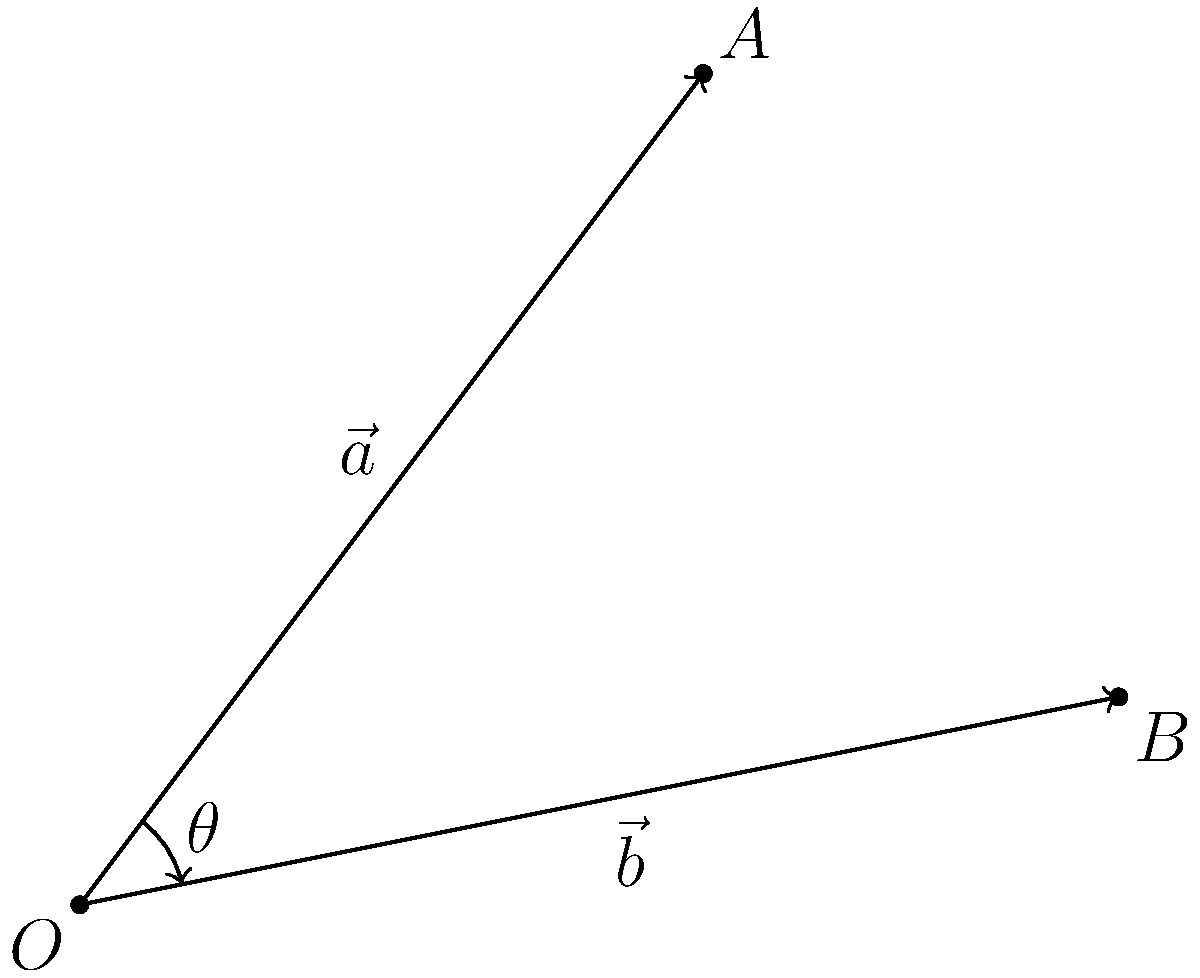In a biotech research project, you're analyzing the interaction between two protein vectors $\vec{a}$ and $\vec{b}$. Given that $\vec{a} = 3\hat{i} + 4\hat{j}$ and $\vec{b} = 5\hat{i} + \hat{j}$, calculate the angle $\theta$ between these vectors. How might this angle influence the protein binding affinity in your research? To find the angle between two vectors, we can use the dot product formula:

$$\cos \theta = \frac{\vec{a} \cdot \vec{b}}{|\vec{a}||\vec{b}|}$$

Step 1: Calculate the dot product $\vec{a} \cdot \vec{b}$
$$\vec{a} \cdot \vec{b} = (3)(5) + (4)(1) = 15 + 4 = 19$$

Step 2: Calculate the magnitudes of $\vec{a}$ and $\vec{b}$
$$|\vec{a}| = \sqrt{3^2 + 4^2} = \sqrt{9 + 16} = \sqrt{25} = 5$$
$$|\vec{b}| = \sqrt{5^2 + 1^2} = \sqrt{25 + 1} = \sqrt{26}$$

Step 3: Apply the formula
$$\cos \theta = \frac{19}{5\sqrt{26}}$$

Step 4: Take the inverse cosine (arccos) of both sides
$$\theta = \arccos\left(\frac{19}{5\sqrt{26}}\right)$$

Step 5: Calculate the result
$$\theta \approx 0.3398 \text{ radians} \approx 19.47°$$

In biotech research, this angle could significantly influence protein binding affinity. A smaller angle might indicate stronger alignment and potential for tighter binding, while a larger angle could suggest weaker interaction. This information is crucial for understanding protein-protein interactions and designing effective therapeutics.
Answer: $\theta \approx 19.47°$ 